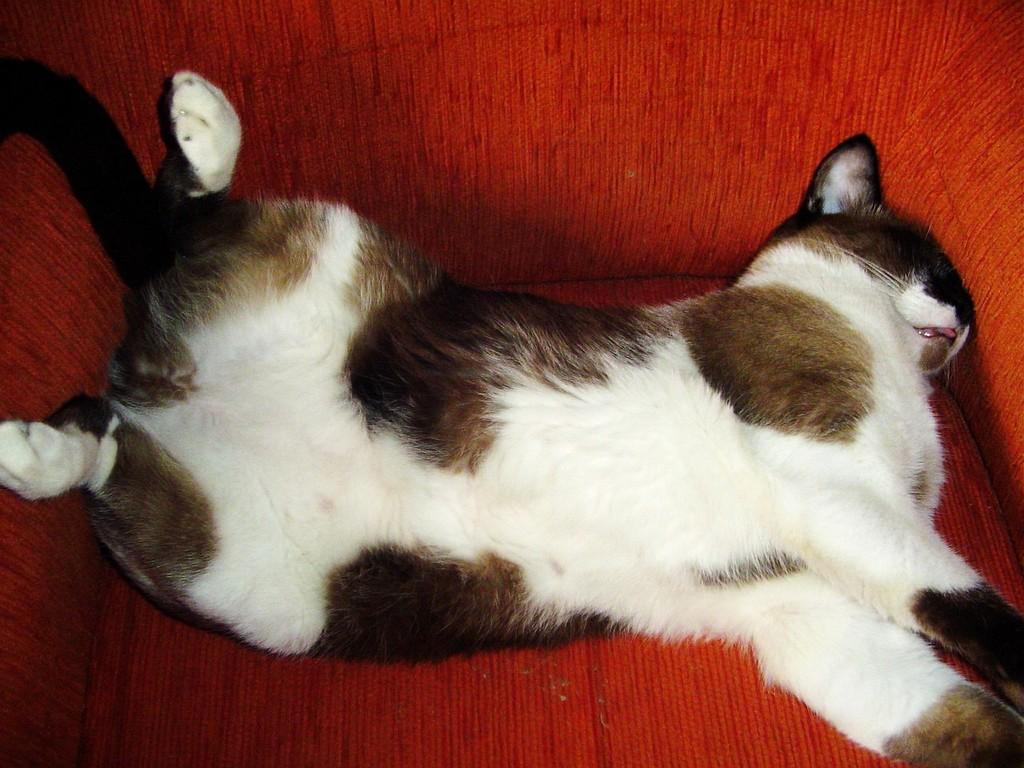What type of animal is in the image? There is a cat in the image. What is the cat sitting or standing on? The cat is on a red color object. What type of cracker is the cat holding in its paws in the image? There is no cracker present in the image, and the cat is not holding anything in its paws. 